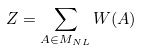<formula> <loc_0><loc_0><loc_500><loc_500>Z = \sum _ { A \in M _ { N L } } W ( A )</formula> 